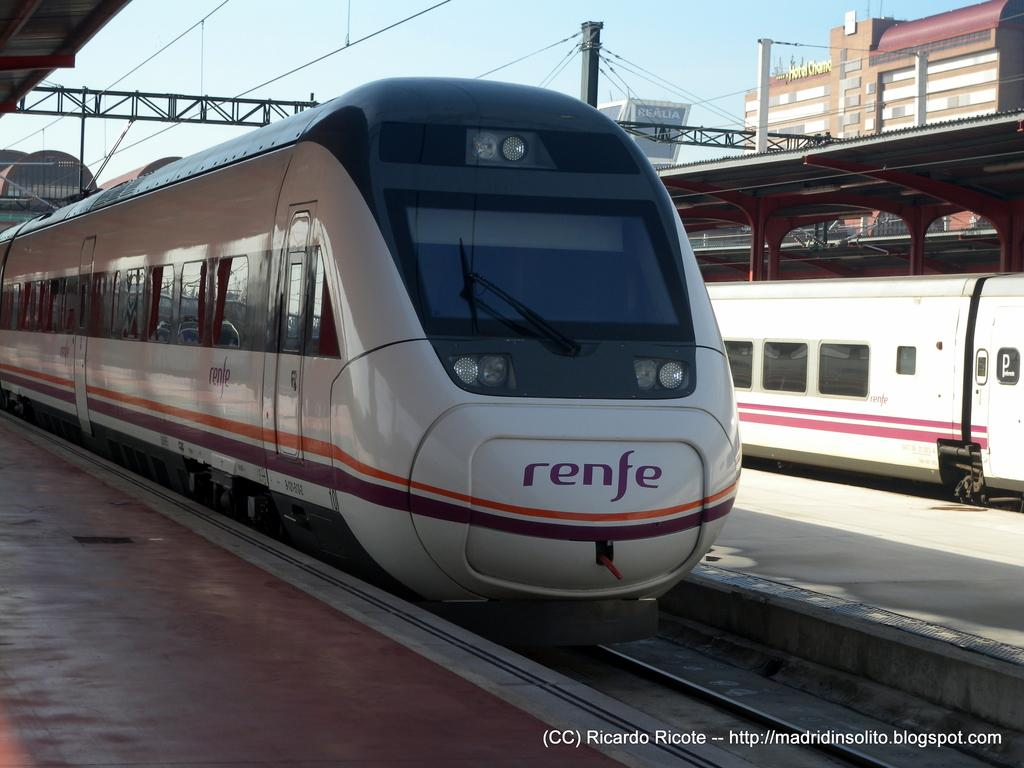What is the main subject of the image? The main subject of the image is trains on a track. What can be seen above the track? There are wires visible above the track. What is located beside the train? There is a platform beside the train. What is visible in the top right corner of the image? There is a building in the top right corner of the image. What type of poison is being used by the ladybug in the image? There is no ladybug present in the image, and therefore no poison can be observed. 